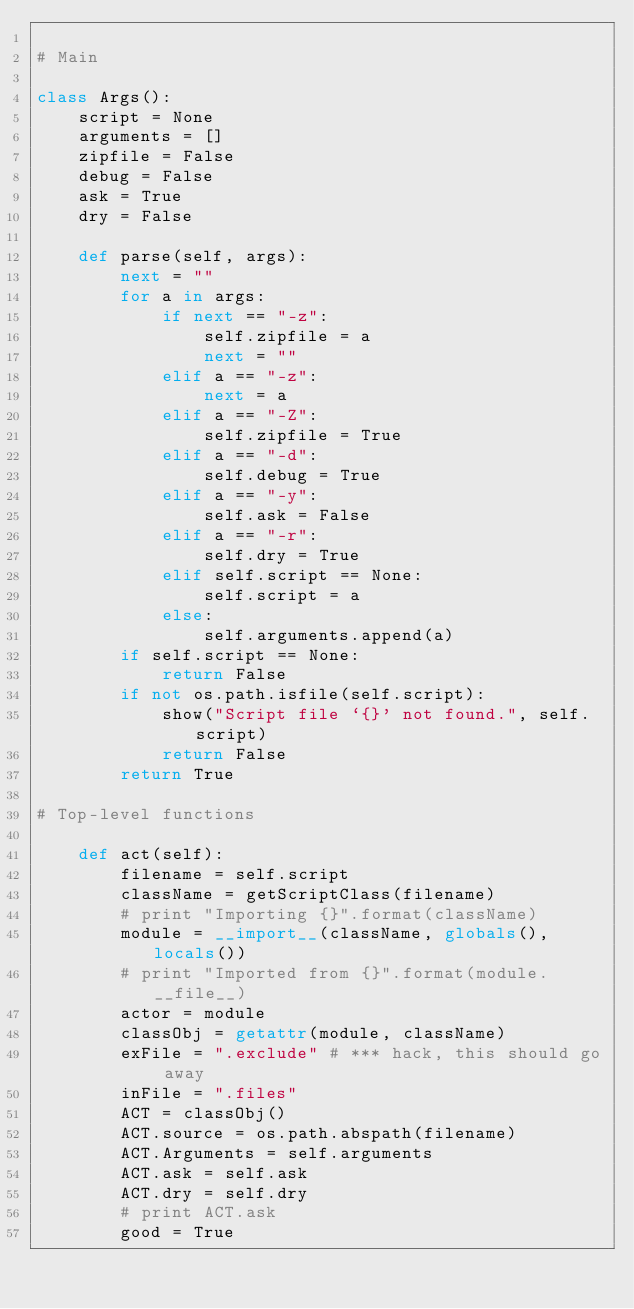Convert code to text. <code><loc_0><loc_0><loc_500><loc_500><_Python_>
# Main

class Args():
    script = None
    arguments = []
    zipfile = False
    debug = False
    ask = True
    dry = False

    def parse(self, args):
        next = ""
        for a in args:
            if next == "-z":
                self.zipfile = a
                next = ""
            elif a == "-z":
                next = a
            elif a == "-Z":
                self.zipfile = True
            elif a == "-d":
                self.debug = True
            elif a == "-y":
                self.ask = False
            elif a == "-r":
                self.dry = True
            elif self.script == None:
                self.script = a
            else:
                self.arguments.append(a)
        if self.script == None:
            return False
        if not os.path.isfile(self.script):
            show("Script file `{}' not found.", self.script)
            return False
        return True

# Top-level functions

    def act(self):
        filename = self.script
        className = getScriptClass(filename)
        # print "Importing {}".format(className)
        module = __import__(className, globals(), locals())
        # print "Imported from {}".format(module.__file__)
        actor = module
        classObj = getattr(module, className)
        exFile = ".exclude" # *** hack, this should go away
        inFile = ".files"
        ACT = classObj()
        ACT.source = os.path.abspath(filename)
        ACT.Arguments = self.arguments
        ACT.ask = self.ask
        ACT.dry = self.dry
        # print ACT.ask
        good = True
</code> 